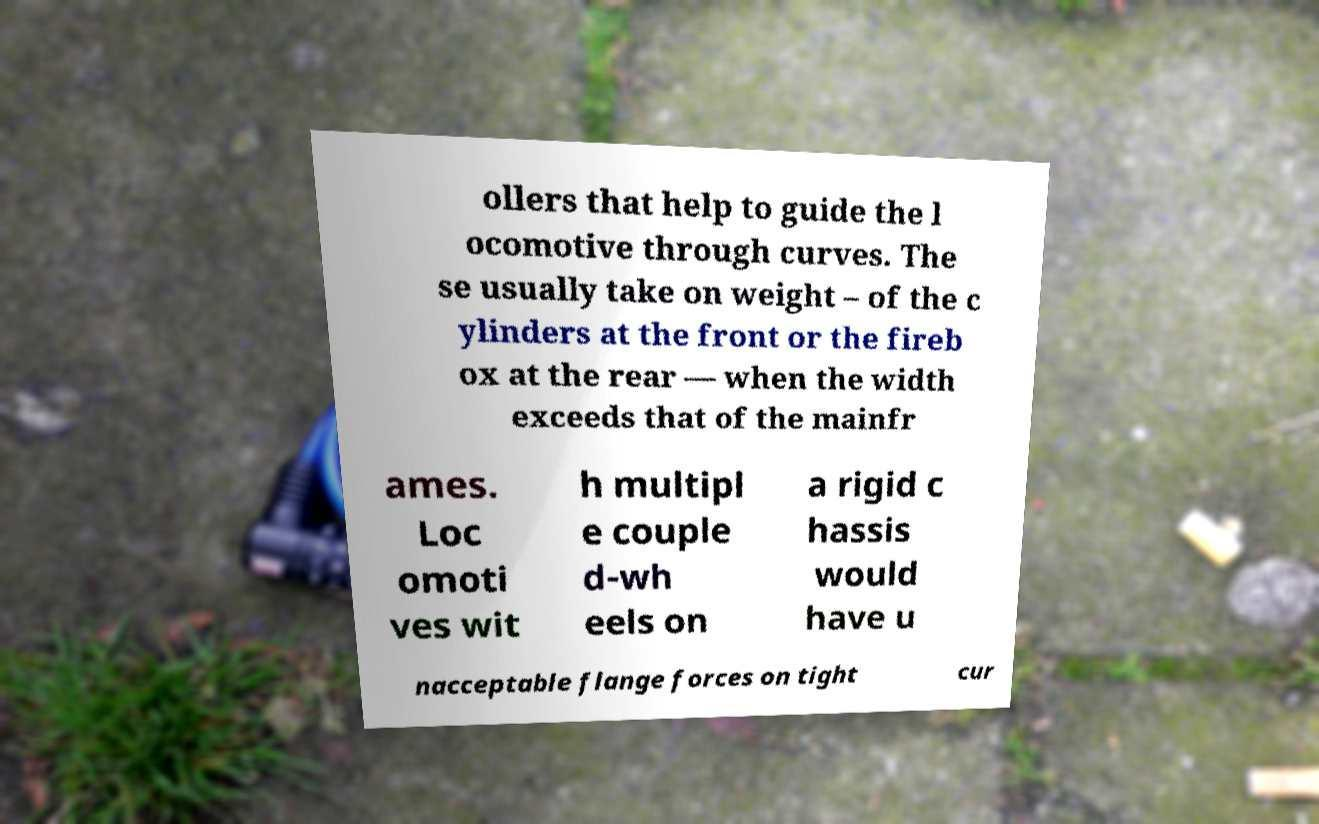There's text embedded in this image that I need extracted. Can you transcribe it verbatim? ollers that help to guide the l ocomotive through curves. The se usually take on weight – of the c ylinders at the front or the fireb ox at the rear — when the width exceeds that of the mainfr ames. Loc omoti ves wit h multipl e couple d-wh eels on a rigid c hassis would have u nacceptable flange forces on tight cur 